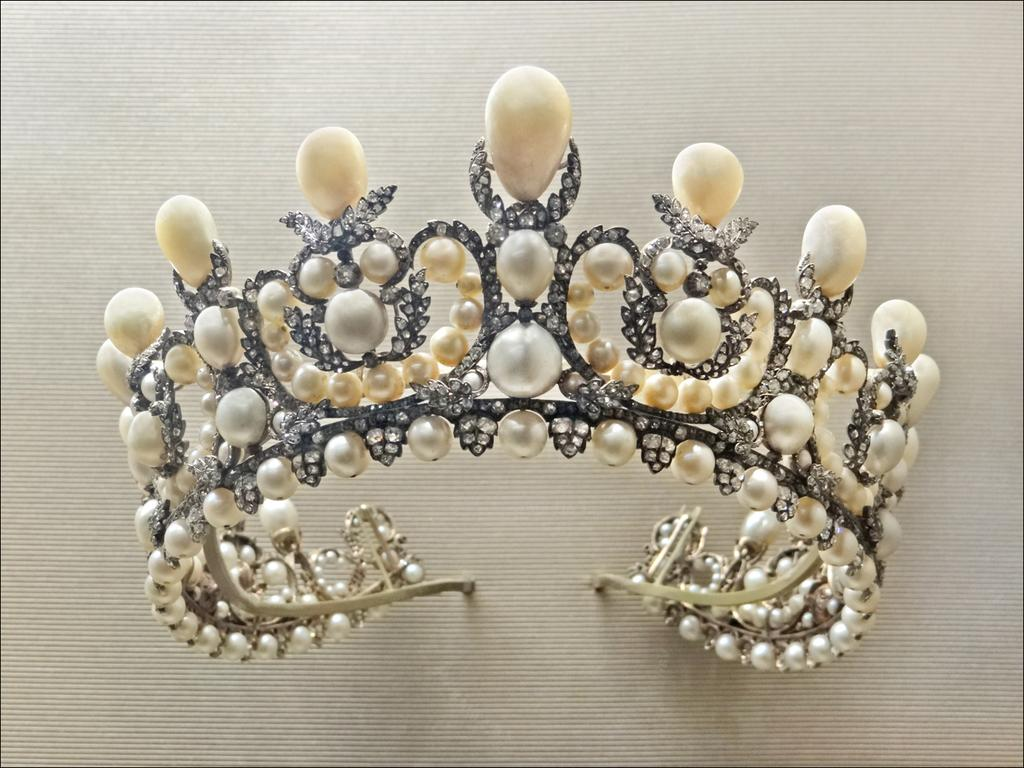What is the main object in the image? There is a crown in the image. What materials were used to make the crown? The crown is made with pearls and stones. On what surface is the crown placed? The crown is placed on a white surface. What type of school is advertised on the crown in the image? There is no school or advertisement present in the image; it only features a crown made with pearls and stones. 